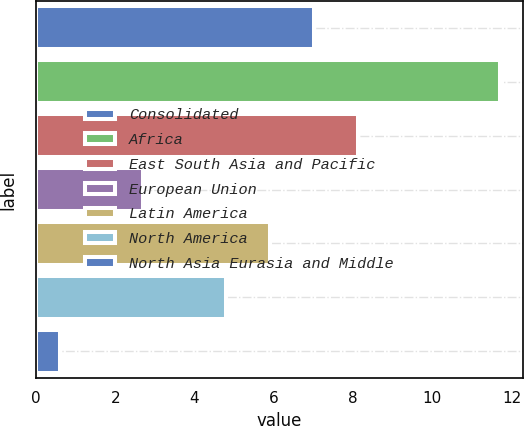Convert chart. <chart><loc_0><loc_0><loc_500><loc_500><bar_chart><fcel>Consolidated<fcel>Africa<fcel>East South Asia and Pacific<fcel>European Union<fcel>Latin America<fcel>North America<fcel>North Asia Eurasia and Middle<nl><fcel>7.02<fcel>11.7<fcel>8.13<fcel>2.7<fcel>5.91<fcel>4.8<fcel>0.6<nl></chart> 